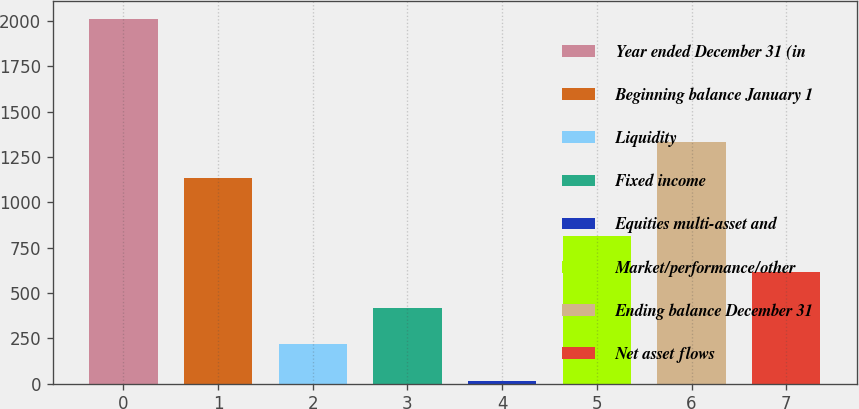Convert chart. <chart><loc_0><loc_0><loc_500><loc_500><bar_chart><fcel>Year ended December 31 (in<fcel>Beginning balance January 1<fcel>Liquidity<fcel>Fixed income<fcel>Equities multi-asset and<fcel>Market/performance/other<fcel>Ending balance December 31<fcel>Net asset flows<nl><fcel>2009<fcel>1133<fcel>216.2<fcel>415.4<fcel>17<fcel>813.8<fcel>1332.2<fcel>614.6<nl></chart> 